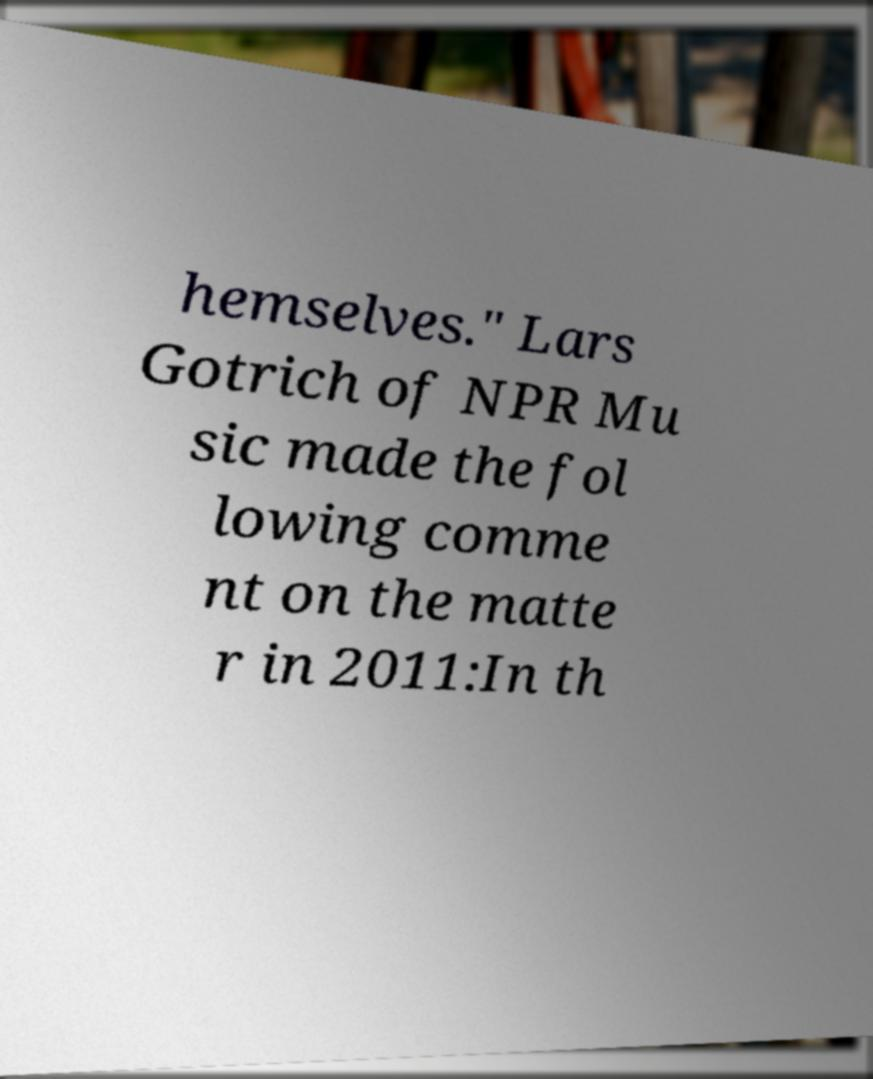Can you read and provide the text displayed in the image?This photo seems to have some interesting text. Can you extract and type it out for me? hemselves." Lars Gotrich of NPR Mu sic made the fol lowing comme nt on the matte r in 2011:In th 